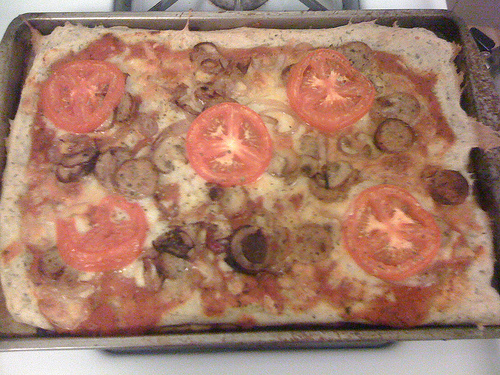<image>
Can you confirm if the tomato is on the mushroom? No. The tomato is not positioned on the mushroom. They may be near each other, but the tomato is not supported by or resting on top of the mushroom. 